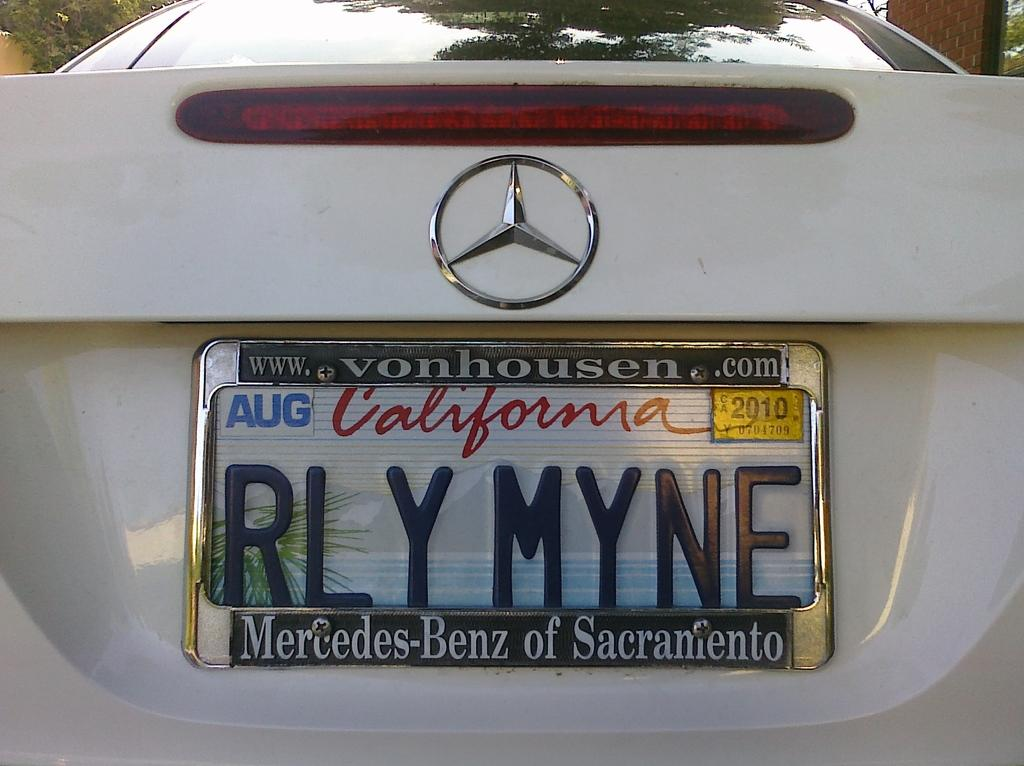<image>
Share a concise interpretation of the image provided. A white Mercedes-Benz with a personalized plate was purchased at a Sacramento dealership. 